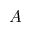<formula> <loc_0><loc_0><loc_500><loc_500>A</formula> 